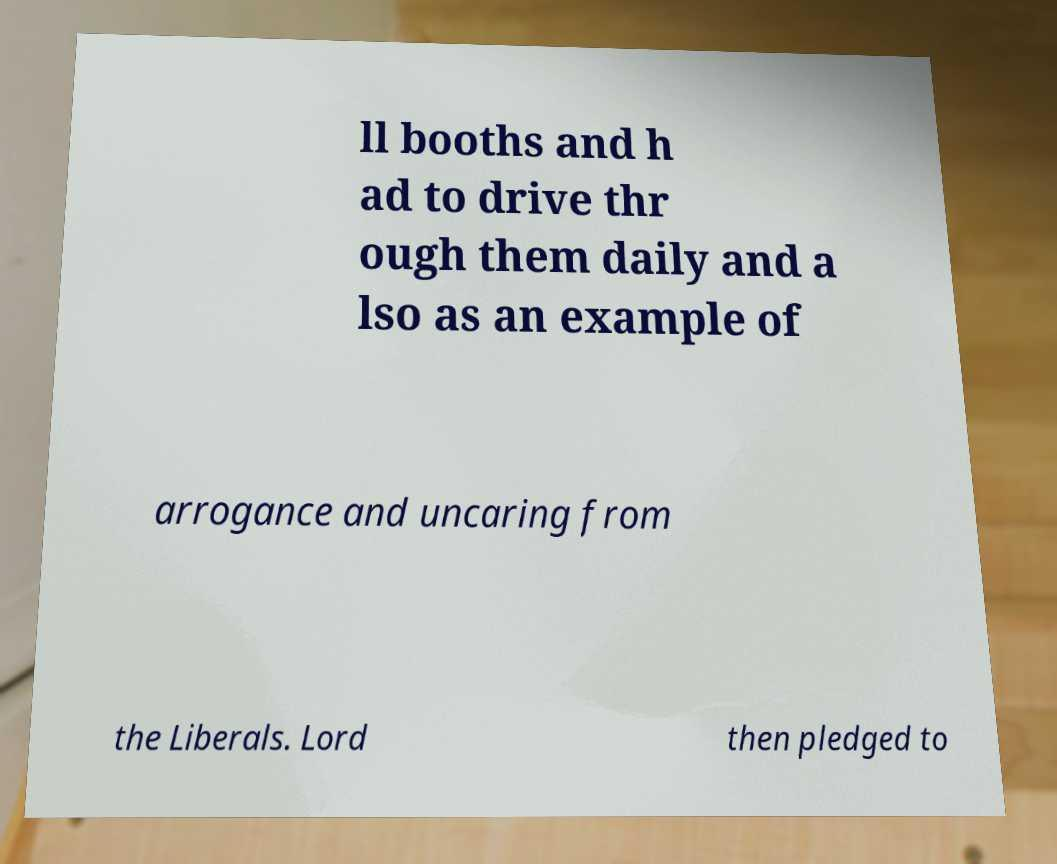Please read and relay the text visible in this image. What does it say? ll booths and h ad to drive thr ough them daily and a lso as an example of arrogance and uncaring from the Liberals. Lord then pledged to 